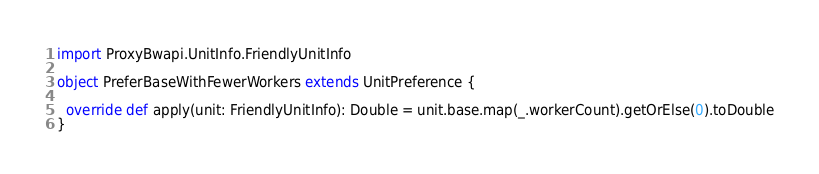<code> <loc_0><loc_0><loc_500><loc_500><_Scala_>import ProxyBwapi.UnitInfo.FriendlyUnitInfo

object PreferBaseWithFewerWorkers extends UnitPreference {
  
  override def apply(unit: FriendlyUnitInfo): Double = unit.base.map(_.workerCount).getOrElse(0).toDouble
}
</code> 